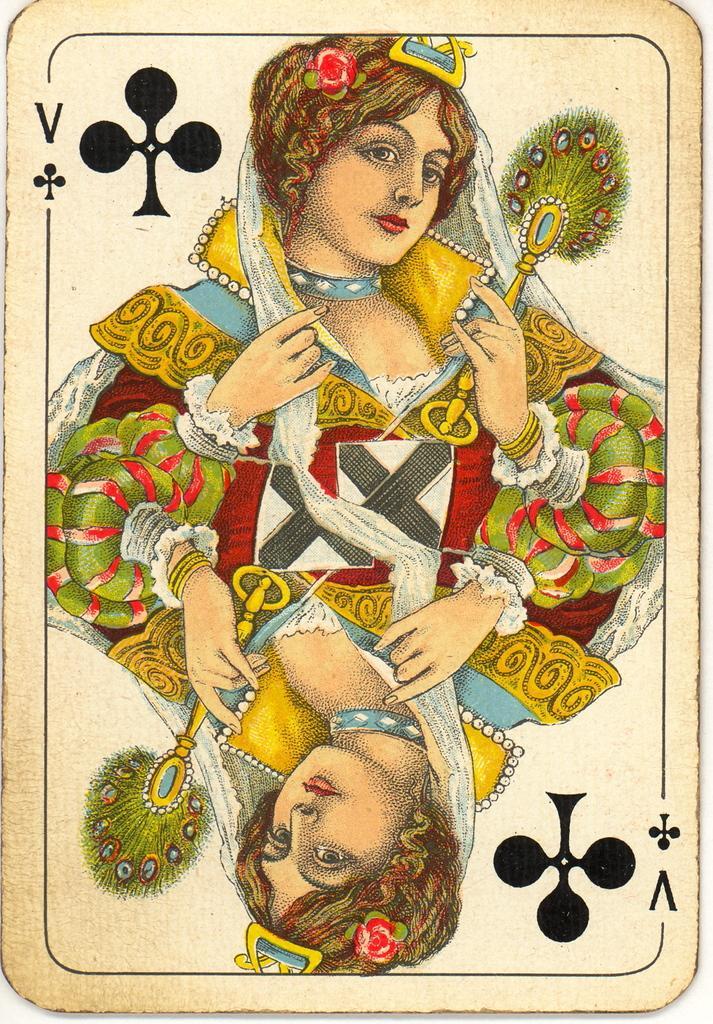How would you summarize this image in a sentence or two? In this picture there is a queen at the top and bottom side of the image, on a card. 